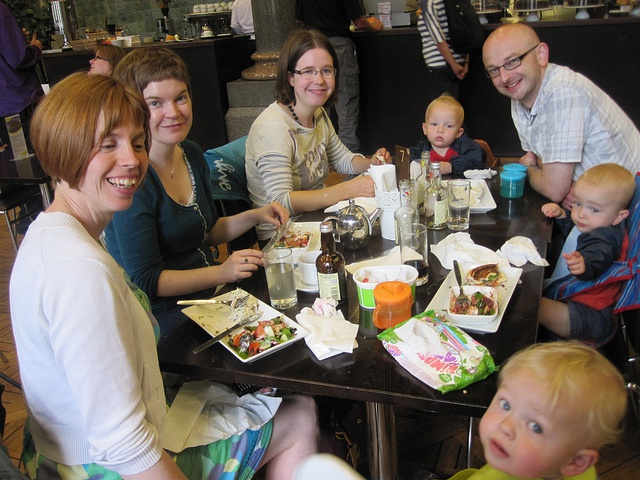Describe the objects in this image and their specific colors. I can see people in black, lavender, tan, darkgray, and maroon tones, dining table in black, lightgray, beige, and gray tones, people in black, gray, and maroon tones, dining table in black and gray tones, and people in black, gray, tan, maroon, and olive tones in this image. 